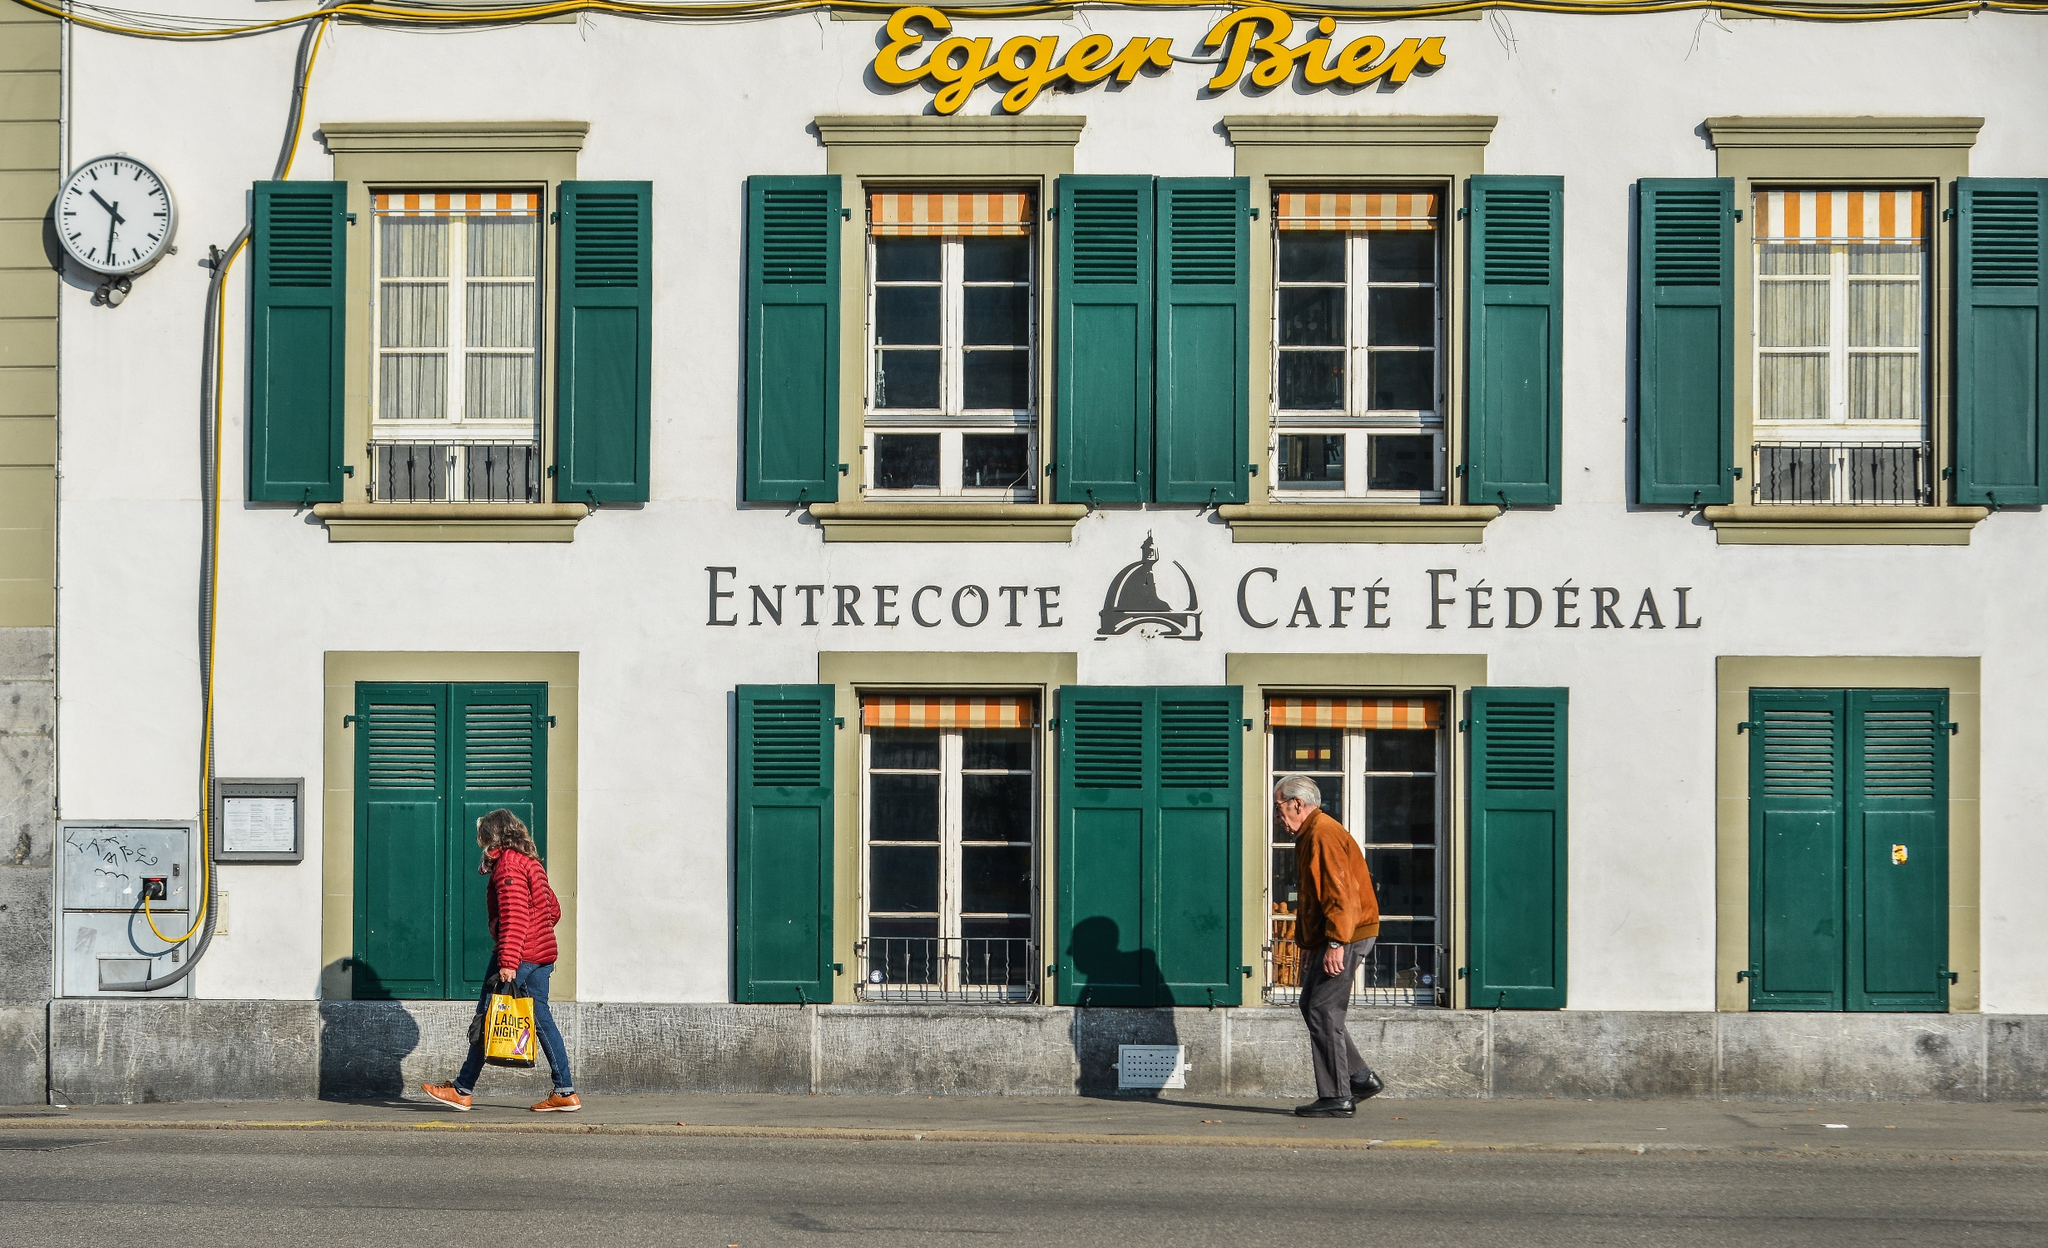Imagine this cafe during a festive holiday. During a festive holiday, 'Entrecote Café Fédéral' would be beautifully decorated with strings of lights, festive ornaments, and perhaps red and green garlands for Christmas. The windows might display scenes of holiday cheer, with wreaths and candles illuminating the night. Inside, the atmosphere is merry and bright, with patrons enjoying seasonal treats such as mulled wine, gingerbread cookies, and a special festive menu. The chatter is lively, laughter is abundant, and a pianist might be playing holiday tunes, spreading joy and warmth to all who visit. 